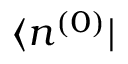<formula> <loc_0><loc_0><loc_500><loc_500>\langle n ^ { ( 0 ) } |</formula> 